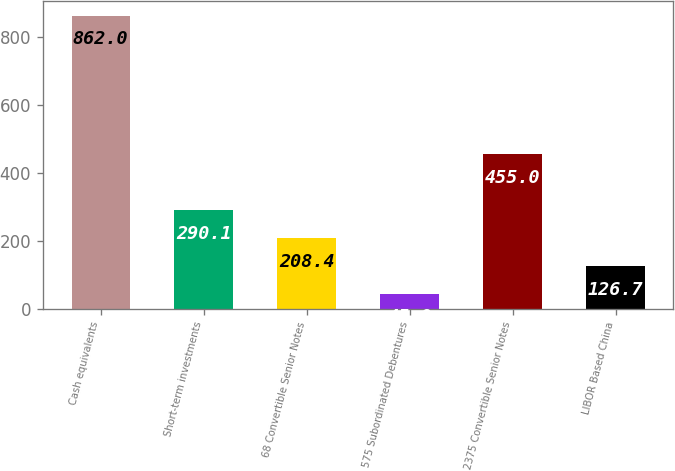Convert chart. <chart><loc_0><loc_0><loc_500><loc_500><bar_chart><fcel>Cash equivalents<fcel>Short-term investments<fcel>68 Convertible Senior Notes<fcel>575 Subordinated Debentures<fcel>2375 Convertible Senior Notes<fcel>LIBOR Based China<nl><fcel>862<fcel>290.1<fcel>208.4<fcel>45<fcel>455<fcel>126.7<nl></chart> 